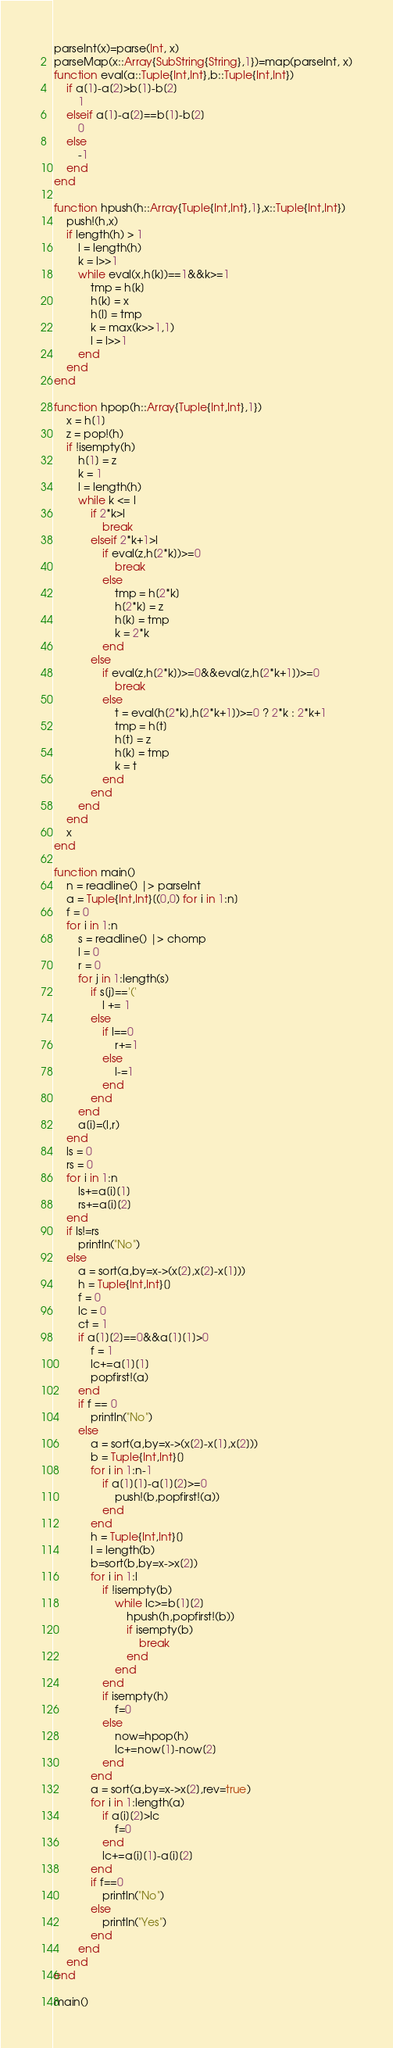<code> <loc_0><loc_0><loc_500><loc_500><_Julia_>parseInt(x)=parse(Int, x)
parseMap(x::Array{SubString{String},1})=map(parseInt, x)
function eval(a::Tuple{Int,Int},b::Tuple{Int,Int})
	if a[1]-a[2]>b[1]-b[2]
		1
	elseif a[1]-a[2]==b[1]-b[2]
		0
	else
		-1
	end
end

function hpush(h::Array{Tuple{Int,Int},1},x::Tuple{Int,Int})
	push!(h,x)
	if length(h) > 1
		l = length(h)
		k = l>>1
		while eval(x,h[k])==1&&k>=1
			tmp = h[k]
			h[k] = x
			h[l] = tmp
			k = max(k>>1,1)
			l = l>>1
		end
	end
end

function hpop(h::Array{Tuple{Int,Int},1})
	x = h[1]
	z = pop!(h)
	if !isempty(h)
		h[1] = z
		k = 1
		l = length(h)
		while k <= l
			if 2*k>l
				break
			elseif 2*k+1>l
				if eval(z,h[2*k])>=0
					break
				else
					tmp = h[2*k]
					h[2*k] = z
					h[k] = tmp
					k = 2*k
				end
			else
				if eval(z,h[2*k])>=0&&eval(z,h[2*k+1])>=0
					break
				else
					t = eval(h[2*k],h[2*k+1])>=0 ? 2*k : 2*k+1
					tmp = h[t]
					h[t] = z
					h[k] = tmp
					k = t
				end
			end
		end
	end
	x
end

function main()
	n = readline() |> parseInt
	a = Tuple{Int,Int}[(0,0) for i in 1:n]
	f = 0
	for i in 1:n
		s = readline() |> chomp
		l = 0
		r = 0
		for j in 1:length(s)
			if s[j]=='('
				l += 1
			else
				if l==0
					r+=1
				else
					l-=1
				end
			end
		end
		a[i]=(l,r)
	end
	ls = 0
	rs = 0
	for i in 1:n
		ls+=a[i][1]
		rs+=a[i][2]
	end
	if ls!=rs
		println("No")
	else
		a = sort(a,by=x->(x[2],x[2]-x[1]))
		h = Tuple{Int,Int}[]
		f = 0
		lc = 0
		ct = 1
		if a[1][2]==0&&a[1][1]>0
			f = 1
			lc+=a[1][1]
			popfirst!(a)
		end
		if f == 0
			println("No")
		else
			a = sort(a,by=x->(x[2]-x[1],x[2]))
			b = Tuple{Int,Int}[]
			for i in 1:n-1
				if a[1][1]-a[1][2]>=0
					push!(b,popfirst!(a))
				end
			end
			h = Tuple{Int,Int}[]
			l = length(b)
			b=sort(b,by=x->x[2])
			for i in 1:l
				if !isempty(b)
					while lc>=b[1][2]
						hpush(h,popfirst!(b))
						if isempty(b)
							break
						end
					end
				end
				if isempty(h)
					f=0
				else
					now=hpop(h)
					lc+=now[1]-now[2]
				end
			end
			a = sort(a,by=x->x[2],rev=true)
			for i in 1:length(a)
				if a[i][2]>lc
					f=0
				end
				lc+=a[i][1]-a[i][2]
			end
			if f==0
				println("No")
			else
				println("Yes")
			end
		end
	end
end

main()</code> 